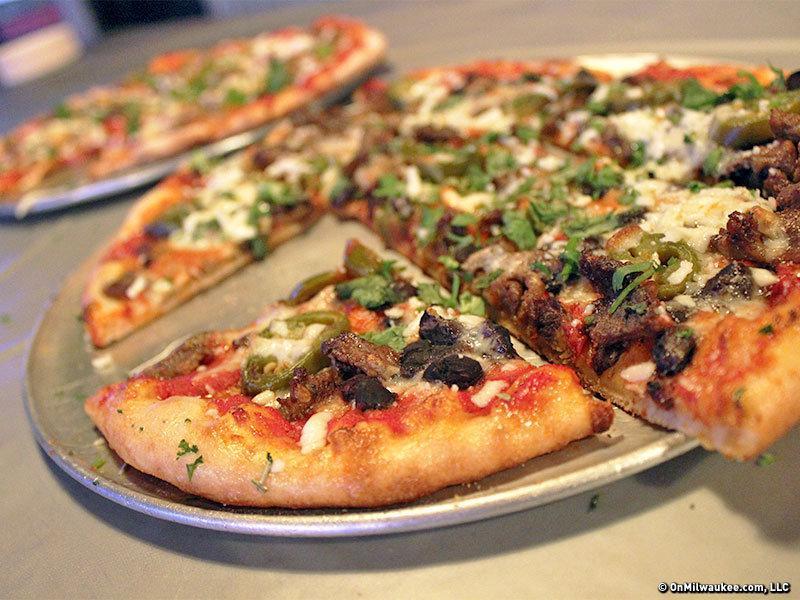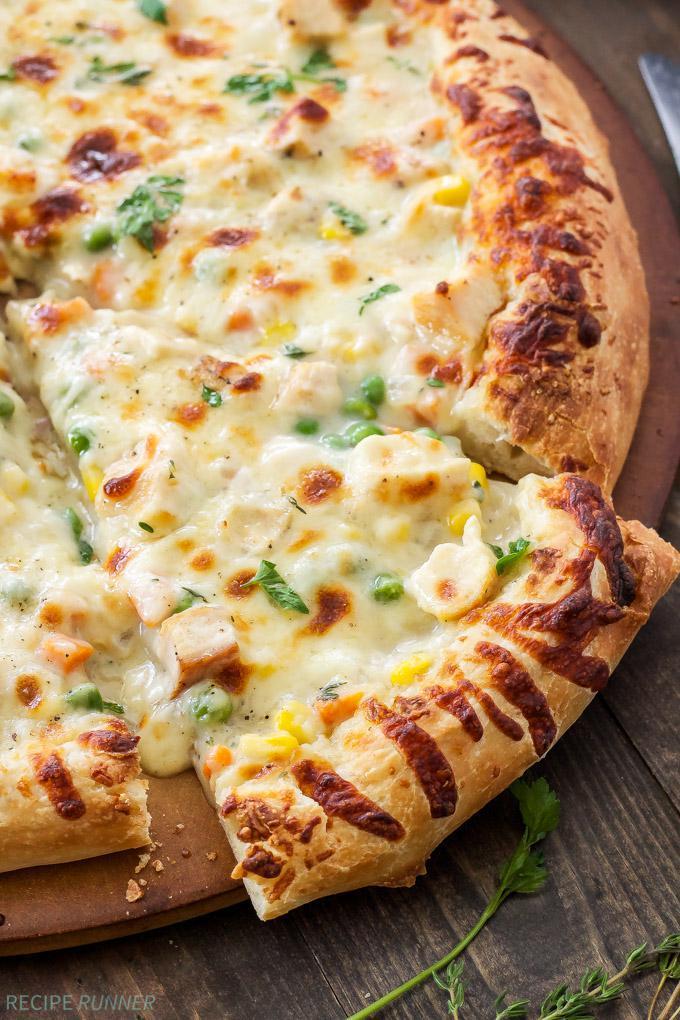The first image is the image on the left, the second image is the image on the right. For the images shown, is this caption "Two pizzas sit in black pans." true? Answer yes or no. No. 